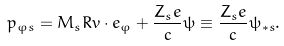Convert formula to latex. <formula><loc_0><loc_0><loc_500><loc_500>p _ { \varphi s } = M _ { s } R v \cdot e _ { \varphi } + \frac { Z _ { s } e } { c } \psi \equiv \frac { Z _ { s } e } { c } \psi _ { \ast s } .</formula> 